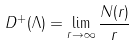<formula> <loc_0><loc_0><loc_500><loc_500>D ^ { + } ( \Lambda ) = \lim _ { r \to \infty } \frac { N ( r ) } { r }</formula> 